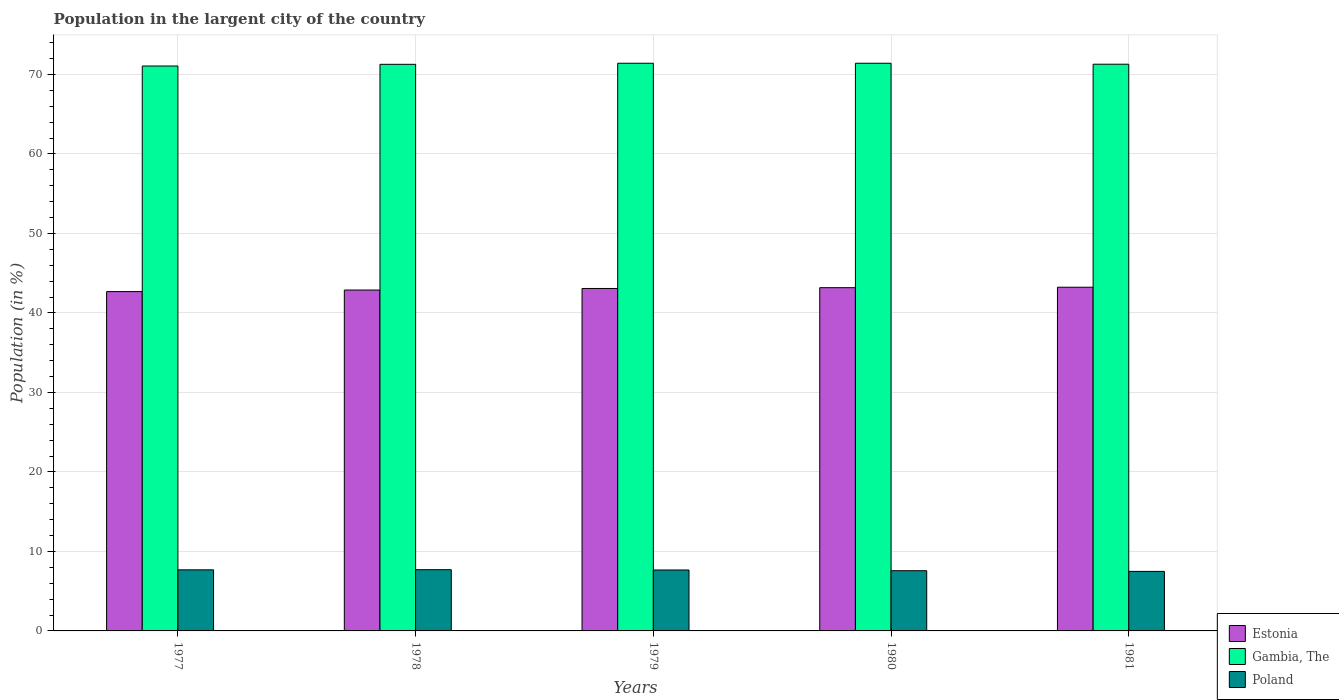How many different coloured bars are there?
Give a very brief answer. 3. How many groups of bars are there?
Offer a terse response. 5. Are the number of bars on each tick of the X-axis equal?
Your response must be concise. Yes. How many bars are there on the 5th tick from the left?
Ensure brevity in your answer.  3. What is the label of the 1st group of bars from the left?
Make the answer very short. 1977. In how many cases, is the number of bars for a given year not equal to the number of legend labels?
Ensure brevity in your answer.  0. What is the percentage of population in the largent city in Gambia, The in 1978?
Offer a very short reply. 71.27. Across all years, what is the maximum percentage of population in the largent city in Poland?
Offer a very short reply. 7.7. Across all years, what is the minimum percentage of population in the largent city in Poland?
Provide a succinct answer. 7.49. In which year was the percentage of population in the largent city in Poland maximum?
Provide a succinct answer. 1978. In which year was the percentage of population in the largent city in Poland minimum?
Offer a terse response. 1981. What is the total percentage of population in the largent city in Gambia, The in the graph?
Keep it short and to the point. 356.43. What is the difference between the percentage of population in the largent city in Estonia in 1977 and that in 1980?
Offer a terse response. -0.49. What is the difference between the percentage of population in the largent city in Gambia, The in 1978 and the percentage of population in the largent city in Poland in 1980?
Offer a very short reply. 63.7. What is the average percentage of population in the largent city in Estonia per year?
Provide a succinct answer. 43.01. In the year 1981, what is the difference between the percentage of population in the largent city in Estonia and percentage of population in the largent city in Poland?
Make the answer very short. 35.75. What is the ratio of the percentage of population in the largent city in Poland in 1977 to that in 1978?
Offer a very short reply. 1. What is the difference between the highest and the second highest percentage of population in the largent city in Poland?
Keep it short and to the point. 0.02. What is the difference between the highest and the lowest percentage of population in the largent city in Estonia?
Provide a succinct answer. 0.55. In how many years, is the percentage of population in the largent city in Gambia, The greater than the average percentage of population in the largent city in Gambia, The taken over all years?
Keep it short and to the point. 3. What does the 1st bar from the left in 1981 represents?
Offer a very short reply. Estonia. What does the 3rd bar from the right in 1978 represents?
Ensure brevity in your answer.  Estonia. Is it the case that in every year, the sum of the percentage of population in the largent city in Gambia, The and percentage of population in the largent city in Poland is greater than the percentage of population in the largent city in Estonia?
Your answer should be compact. Yes. Are all the bars in the graph horizontal?
Offer a terse response. No. Does the graph contain any zero values?
Offer a terse response. No. Does the graph contain grids?
Ensure brevity in your answer.  Yes. How many legend labels are there?
Ensure brevity in your answer.  3. How are the legend labels stacked?
Offer a terse response. Vertical. What is the title of the graph?
Offer a terse response. Population in the largent city of the country. What is the label or title of the X-axis?
Ensure brevity in your answer.  Years. What is the label or title of the Y-axis?
Offer a terse response. Population (in %). What is the Population (in %) in Estonia in 1977?
Your response must be concise. 42.68. What is the Population (in %) of Gambia, The in 1977?
Offer a terse response. 71.06. What is the Population (in %) in Poland in 1977?
Give a very brief answer. 7.68. What is the Population (in %) of Estonia in 1978?
Ensure brevity in your answer.  42.88. What is the Population (in %) in Gambia, The in 1978?
Your response must be concise. 71.27. What is the Population (in %) in Poland in 1978?
Offer a terse response. 7.7. What is the Population (in %) of Estonia in 1979?
Provide a short and direct response. 43.07. What is the Population (in %) of Gambia, The in 1979?
Ensure brevity in your answer.  71.41. What is the Population (in %) of Poland in 1979?
Your response must be concise. 7.66. What is the Population (in %) in Estonia in 1980?
Ensure brevity in your answer.  43.18. What is the Population (in %) of Gambia, The in 1980?
Offer a terse response. 71.41. What is the Population (in %) in Poland in 1980?
Your response must be concise. 7.57. What is the Population (in %) in Estonia in 1981?
Ensure brevity in your answer.  43.23. What is the Population (in %) of Gambia, The in 1981?
Keep it short and to the point. 71.29. What is the Population (in %) of Poland in 1981?
Provide a short and direct response. 7.49. Across all years, what is the maximum Population (in %) in Estonia?
Provide a short and direct response. 43.23. Across all years, what is the maximum Population (in %) of Gambia, The?
Make the answer very short. 71.41. Across all years, what is the maximum Population (in %) in Poland?
Provide a short and direct response. 7.7. Across all years, what is the minimum Population (in %) of Estonia?
Make the answer very short. 42.68. Across all years, what is the minimum Population (in %) of Gambia, The?
Make the answer very short. 71.06. Across all years, what is the minimum Population (in %) in Poland?
Your response must be concise. 7.49. What is the total Population (in %) in Estonia in the graph?
Give a very brief answer. 215.05. What is the total Population (in %) in Gambia, The in the graph?
Offer a terse response. 356.43. What is the total Population (in %) in Poland in the graph?
Offer a terse response. 38.11. What is the difference between the Population (in %) in Estonia in 1977 and that in 1978?
Your answer should be very brief. -0.2. What is the difference between the Population (in %) of Gambia, The in 1977 and that in 1978?
Provide a succinct answer. -0.21. What is the difference between the Population (in %) in Poland in 1977 and that in 1978?
Keep it short and to the point. -0.02. What is the difference between the Population (in %) in Estonia in 1977 and that in 1979?
Your answer should be very brief. -0.39. What is the difference between the Population (in %) of Gambia, The in 1977 and that in 1979?
Your response must be concise. -0.35. What is the difference between the Population (in %) of Poland in 1977 and that in 1979?
Provide a succinct answer. 0.02. What is the difference between the Population (in %) in Estonia in 1977 and that in 1980?
Ensure brevity in your answer.  -0.49. What is the difference between the Population (in %) of Gambia, The in 1977 and that in 1980?
Offer a very short reply. -0.35. What is the difference between the Population (in %) of Poland in 1977 and that in 1980?
Offer a terse response. 0.11. What is the difference between the Population (in %) in Estonia in 1977 and that in 1981?
Offer a very short reply. -0.55. What is the difference between the Population (in %) in Gambia, The in 1977 and that in 1981?
Offer a very short reply. -0.23. What is the difference between the Population (in %) of Poland in 1977 and that in 1981?
Offer a terse response. 0.2. What is the difference between the Population (in %) in Estonia in 1978 and that in 1979?
Give a very brief answer. -0.19. What is the difference between the Population (in %) in Gambia, The in 1978 and that in 1979?
Your response must be concise. -0.13. What is the difference between the Population (in %) in Poland in 1978 and that in 1979?
Offer a terse response. 0.04. What is the difference between the Population (in %) in Estonia in 1978 and that in 1980?
Your answer should be compact. -0.3. What is the difference between the Population (in %) of Gambia, The in 1978 and that in 1980?
Give a very brief answer. -0.13. What is the difference between the Population (in %) of Poland in 1978 and that in 1980?
Your answer should be compact. 0.13. What is the difference between the Population (in %) of Estonia in 1978 and that in 1981?
Keep it short and to the point. -0.35. What is the difference between the Population (in %) of Gambia, The in 1978 and that in 1981?
Offer a very short reply. -0.01. What is the difference between the Population (in %) in Poland in 1978 and that in 1981?
Offer a terse response. 0.21. What is the difference between the Population (in %) of Estonia in 1979 and that in 1980?
Ensure brevity in your answer.  -0.1. What is the difference between the Population (in %) in Gambia, The in 1979 and that in 1980?
Provide a succinct answer. -0. What is the difference between the Population (in %) of Poland in 1979 and that in 1980?
Your answer should be very brief. 0.09. What is the difference between the Population (in %) in Estonia in 1979 and that in 1981?
Make the answer very short. -0.16. What is the difference between the Population (in %) of Gambia, The in 1979 and that in 1981?
Ensure brevity in your answer.  0.12. What is the difference between the Population (in %) of Poland in 1979 and that in 1981?
Your response must be concise. 0.18. What is the difference between the Population (in %) of Estonia in 1980 and that in 1981?
Keep it short and to the point. -0.06. What is the difference between the Population (in %) in Gambia, The in 1980 and that in 1981?
Give a very brief answer. 0.12. What is the difference between the Population (in %) of Poland in 1980 and that in 1981?
Keep it short and to the point. 0.09. What is the difference between the Population (in %) of Estonia in 1977 and the Population (in %) of Gambia, The in 1978?
Provide a succinct answer. -28.59. What is the difference between the Population (in %) in Estonia in 1977 and the Population (in %) in Poland in 1978?
Keep it short and to the point. 34.98. What is the difference between the Population (in %) in Gambia, The in 1977 and the Population (in %) in Poland in 1978?
Keep it short and to the point. 63.36. What is the difference between the Population (in %) in Estonia in 1977 and the Population (in %) in Gambia, The in 1979?
Provide a short and direct response. -28.72. What is the difference between the Population (in %) in Estonia in 1977 and the Population (in %) in Poland in 1979?
Provide a short and direct response. 35.02. What is the difference between the Population (in %) in Gambia, The in 1977 and the Population (in %) in Poland in 1979?
Your answer should be very brief. 63.4. What is the difference between the Population (in %) in Estonia in 1977 and the Population (in %) in Gambia, The in 1980?
Offer a very short reply. -28.72. What is the difference between the Population (in %) of Estonia in 1977 and the Population (in %) of Poland in 1980?
Offer a very short reply. 35.11. What is the difference between the Population (in %) of Gambia, The in 1977 and the Population (in %) of Poland in 1980?
Ensure brevity in your answer.  63.49. What is the difference between the Population (in %) in Estonia in 1977 and the Population (in %) in Gambia, The in 1981?
Offer a terse response. -28.6. What is the difference between the Population (in %) of Estonia in 1977 and the Population (in %) of Poland in 1981?
Ensure brevity in your answer.  35.2. What is the difference between the Population (in %) of Gambia, The in 1977 and the Population (in %) of Poland in 1981?
Provide a short and direct response. 63.57. What is the difference between the Population (in %) in Estonia in 1978 and the Population (in %) in Gambia, The in 1979?
Offer a terse response. -28.53. What is the difference between the Population (in %) in Estonia in 1978 and the Population (in %) in Poland in 1979?
Keep it short and to the point. 35.22. What is the difference between the Population (in %) in Gambia, The in 1978 and the Population (in %) in Poland in 1979?
Offer a very short reply. 63.61. What is the difference between the Population (in %) in Estonia in 1978 and the Population (in %) in Gambia, The in 1980?
Ensure brevity in your answer.  -28.53. What is the difference between the Population (in %) in Estonia in 1978 and the Population (in %) in Poland in 1980?
Ensure brevity in your answer.  35.31. What is the difference between the Population (in %) in Gambia, The in 1978 and the Population (in %) in Poland in 1980?
Your answer should be compact. 63.7. What is the difference between the Population (in %) in Estonia in 1978 and the Population (in %) in Gambia, The in 1981?
Provide a short and direct response. -28.41. What is the difference between the Population (in %) of Estonia in 1978 and the Population (in %) of Poland in 1981?
Offer a very short reply. 35.39. What is the difference between the Population (in %) of Gambia, The in 1978 and the Population (in %) of Poland in 1981?
Provide a succinct answer. 63.78. What is the difference between the Population (in %) in Estonia in 1979 and the Population (in %) in Gambia, The in 1980?
Keep it short and to the point. -28.33. What is the difference between the Population (in %) in Estonia in 1979 and the Population (in %) in Poland in 1980?
Offer a very short reply. 35.5. What is the difference between the Population (in %) of Gambia, The in 1979 and the Population (in %) of Poland in 1980?
Make the answer very short. 63.83. What is the difference between the Population (in %) in Estonia in 1979 and the Population (in %) in Gambia, The in 1981?
Ensure brevity in your answer.  -28.21. What is the difference between the Population (in %) in Estonia in 1979 and the Population (in %) in Poland in 1981?
Make the answer very short. 35.59. What is the difference between the Population (in %) of Gambia, The in 1979 and the Population (in %) of Poland in 1981?
Provide a short and direct response. 63.92. What is the difference between the Population (in %) in Estonia in 1980 and the Population (in %) in Gambia, The in 1981?
Offer a terse response. -28.11. What is the difference between the Population (in %) in Estonia in 1980 and the Population (in %) in Poland in 1981?
Your answer should be compact. 35.69. What is the difference between the Population (in %) of Gambia, The in 1980 and the Population (in %) of Poland in 1981?
Give a very brief answer. 63.92. What is the average Population (in %) of Estonia per year?
Your answer should be compact. 43.01. What is the average Population (in %) in Gambia, The per year?
Your answer should be very brief. 71.29. What is the average Population (in %) in Poland per year?
Offer a terse response. 7.62. In the year 1977, what is the difference between the Population (in %) of Estonia and Population (in %) of Gambia, The?
Your answer should be very brief. -28.38. In the year 1977, what is the difference between the Population (in %) of Estonia and Population (in %) of Poland?
Make the answer very short. 35. In the year 1977, what is the difference between the Population (in %) of Gambia, The and Population (in %) of Poland?
Your response must be concise. 63.38. In the year 1978, what is the difference between the Population (in %) of Estonia and Population (in %) of Gambia, The?
Offer a very short reply. -28.39. In the year 1978, what is the difference between the Population (in %) of Estonia and Population (in %) of Poland?
Offer a terse response. 35.18. In the year 1978, what is the difference between the Population (in %) of Gambia, The and Population (in %) of Poland?
Offer a very short reply. 63.57. In the year 1979, what is the difference between the Population (in %) of Estonia and Population (in %) of Gambia, The?
Offer a very short reply. -28.33. In the year 1979, what is the difference between the Population (in %) of Estonia and Population (in %) of Poland?
Provide a short and direct response. 35.41. In the year 1979, what is the difference between the Population (in %) of Gambia, The and Population (in %) of Poland?
Give a very brief answer. 63.74. In the year 1980, what is the difference between the Population (in %) in Estonia and Population (in %) in Gambia, The?
Your answer should be compact. -28.23. In the year 1980, what is the difference between the Population (in %) in Estonia and Population (in %) in Poland?
Keep it short and to the point. 35.6. In the year 1980, what is the difference between the Population (in %) of Gambia, The and Population (in %) of Poland?
Your answer should be very brief. 63.83. In the year 1981, what is the difference between the Population (in %) in Estonia and Population (in %) in Gambia, The?
Make the answer very short. -28.05. In the year 1981, what is the difference between the Population (in %) of Estonia and Population (in %) of Poland?
Provide a short and direct response. 35.75. In the year 1981, what is the difference between the Population (in %) in Gambia, The and Population (in %) in Poland?
Offer a very short reply. 63.8. What is the ratio of the Population (in %) in Estonia in 1977 to that in 1978?
Your answer should be compact. 1. What is the ratio of the Population (in %) of Poland in 1977 to that in 1978?
Make the answer very short. 1. What is the ratio of the Population (in %) in Estonia in 1977 to that in 1979?
Ensure brevity in your answer.  0.99. What is the ratio of the Population (in %) in Gambia, The in 1977 to that in 1979?
Your answer should be compact. 1. What is the ratio of the Population (in %) in Poland in 1977 to that in 1979?
Keep it short and to the point. 1. What is the ratio of the Population (in %) in Estonia in 1977 to that in 1980?
Your response must be concise. 0.99. What is the ratio of the Population (in %) in Gambia, The in 1977 to that in 1980?
Provide a short and direct response. 1. What is the ratio of the Population (in %) in Poland in 1977 to that in 1980?
Your answer should be very brief. 1.01. What is the ratio of the Population (in %) in Estonia in 1977 to that in 1981?
Make the answer very short. 0.99. What is the ratio of the Population (in %) of Poland in 1977 to that in 1981?
Ensure brevity in your answer.  1.03. What is the ratio of the Population (in %) of Gambia, The in 1978 to that in 1979?
Ensure brevity in your answer.  1. What is the ratio of the Population (in %) in Poland in 1978 to that in 1979?
Your answer should be compact. 1. What is the ratio of the Population (in %) in Estonia in 1978 to that in 1980?
Offer a very short reply. 0.99. What is the ratio of the Population (in %) in Poland in 1978 to that in 1980?
Offer a very short reply. 1.02. What is the ratio of the Population (in %) in Estonia in 1978 to that in 1981?
Provide a succinct answer. 0.99. What is the ratio of the Population (in %) in Poland in 1978 to that in 1981?
Your response must be concise. 1.03. What is the ratio of the Population (in %) in Estonia in 1979 to that in 1980?
Give a very brief answer. 1. What is the ratio of the Population (in %) in Poland in 1979 to that in 1980?
Offer a very short reply. 1.01. What is the ratio of the Population (in %) of Estonia in 1979 to that in 1981?
Offer a very short reply. 1. What is the ratio of the Population (in %) in Gambia, The in 1979 to that in 1981?
Provide a succinct answer. 1. What is the ratio of the Population (in %) of Poland in 1979 to that in 1981?
Your answer should be compact. 1.02. What is the ratio of the Population (in %) of Poland in 1980 to that in 1981?
Make the answer very short. 1.01. What is the difference between the highest and the second highest Population (in %) in Estonia?
Provide a short and direct response. 0.06. What is the difference between the highest and the second highest Population (in %) of Gambia, The?
Your response must be concise. 0. What is the difference between the highest and the second highest Population (in %) in Poland?
Give a very brief answer. 0.02. What is the difference between the highest and the lowest Population (in %) of Estonia?
Your answer should be very brief. 0.55. What is the difference between the highest and the lowest Population (in %) in Gambia, The?
Ensure brevity in your answer.  0.35. What is the difference between the highest and the lowest Population (in %) of Poland?
Make the answer very short. 0.21. 